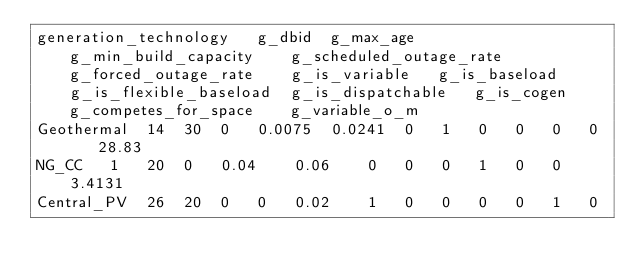<code> <loc_0><loc_0><loc_500><loc_500><_SQL_>generation_technology	g_dbid	g_max_age	g_min_build_capacity	g_scheduled_outage_rate	g_forced_outage_rate	g_is_variable	g_is_baseload	g_is_flexible_baseload	g_is_dispatchable	g_is_cogen	g_competes_for_space	g_variable_o_m
Geothermal	14	30	0	0.0075	0.0241	0	1	0	0	0	0	28.83
NG_CC	1	20	0	0.04	0.06	0	0	0	1	0	0	3.4131
Central_PV	26	20	0	0	0.02	1	0	0	0	0	1	0
</code> 